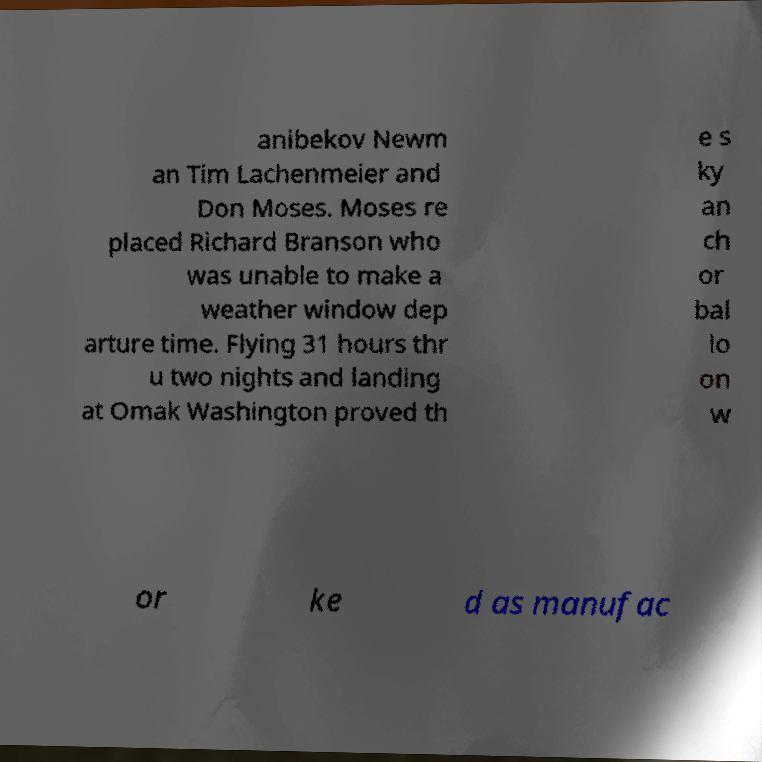Can you read and provide the text displayed in the image?This photo seems to have some interesting text. Can you extract and type it out for me? anibekov Newm an Tim Lachenmeier and Don Moses. Moses re placed Richard Branson who was unable to make a weather window dep arture time. Flying 31 hours thr u two nights and landing at Omak Washington proved th e s ky an ch or bal lo on w or ke d as manufac 